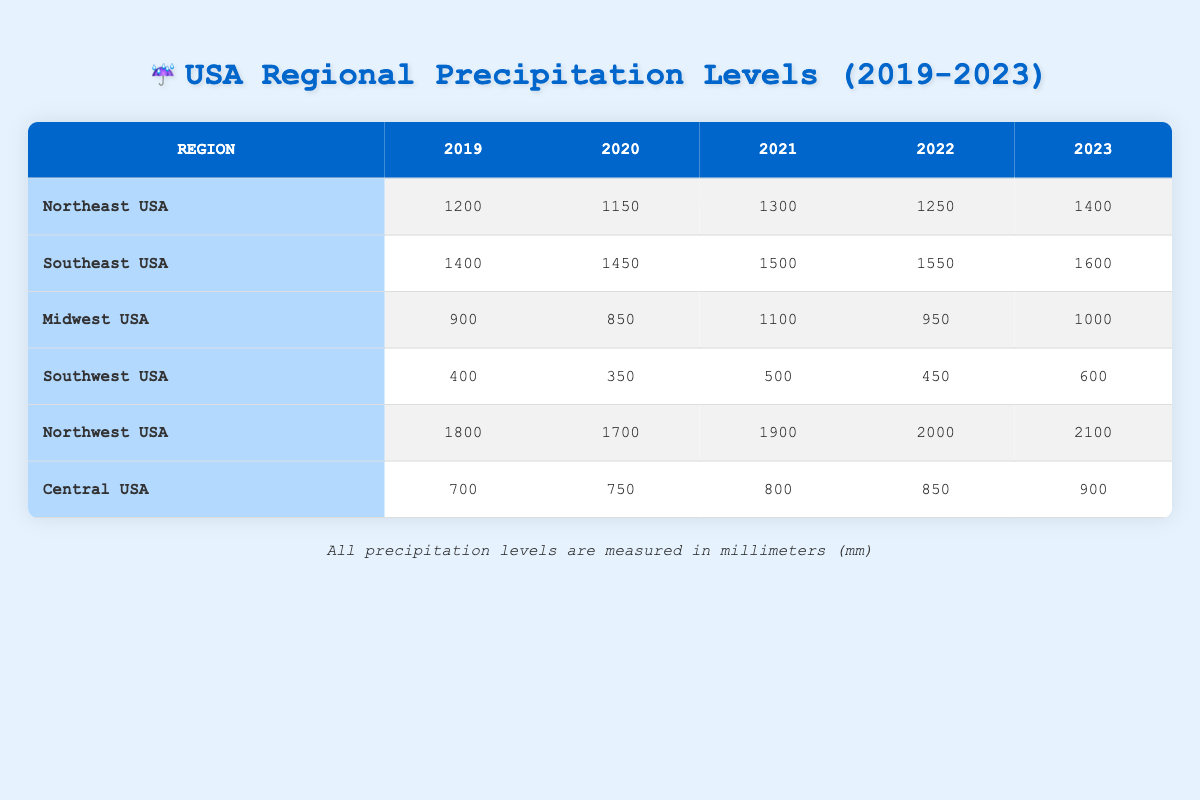What was the precipitation level in the Southeast USA in 2021? Looking at the Southeast USA row in the table, the precipitation level for the year 2021 is clearly listed as 1500 mm.
Answer: 1500 mm Which region had the lowest precipitation level in 2020? By comparing the precipitation levels for each region in the year 2020, the Southwest USA is the lowest at 350 mm.
Answer: Southwest USA What is the total precipitation in the Northeast USA from 2019 to 2023? The individual precipitation levels from 2019 (1200 mm), 2020 (1150 mm), 2021 (1300 mm), 2022 (1250 mm), and 2023 (1400 mm) add up to a total of 1200 + 1150 + 1300 + 1250 + 1400 = 6300 mm.
Answer: 6300 mm Did the precipitation level in the Midwest USA increase from 2019 to 2023? The precipitation levels are as follows: 2019 (900 mm) and 2023 (1000 mm). Since 1000 mm is greater than 900 mm, this indicates an increase.
Answer: Yes What was the average annual precipitation for the Northwestern USA over the last five years? To find the average, sum the precipitation for each year: 1800 + 1700 + 1900 + 2000 + 2100 = 11500 mm. Then, divide by 5 (the number of years): 11500/5 = 2300 mm.
Answer: 2300 mm Which region has the highest average precipitation from 2019 to 2023? The Northwest USA has the highest annual precipitation each year compared to others. The average can be calculated as follows: (1800 + 1700 + 1900 + 2000 + 2100) / 5 = 2300 mm, which is greater than any other region's average.
Answer: Northwest USA How much did precipitation in the Central USA change from 2019 to 2023? The precipitation level in 2019 was 700 mm and in 2023 was 900 mm. The change can be computed as 900 mm - 700 mm = 200 mm.
Answer: Increased by 200 mm Was there a decrease in precipitation for the Southwest USA in 2020 compared to 2019? The level in 2019 was 400 mm and in 2020 was 350 mm. Since 350 mm is less than 400 mm, this confirms there was a decrease.
Answer: Yes What was the difference in precipitation levels between the Northeast USA and the Northwest USA in 2022? For the Northeast USA in 2022, the level is 1250 mm, and for the Northwest USA it is 2000 mm. The difference calculation is 2000 - 1250 = 750 mm, meaning the Northwest USA was significantly wetter.
Answer: 750 mm 